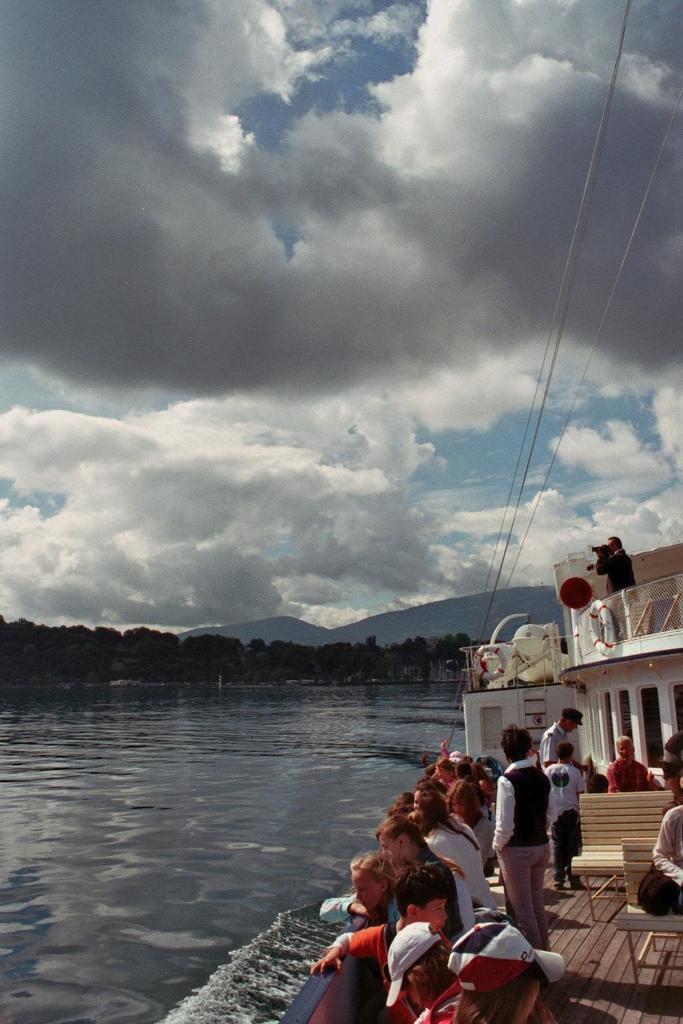How would you summarize this image in a sentence or two? In this image there are a few people standing on the ship and there are a few other people sitting on the chairs. There are tubes. At the bottom of the image there is water. In the background of the image there are trees, mountains and sky. 